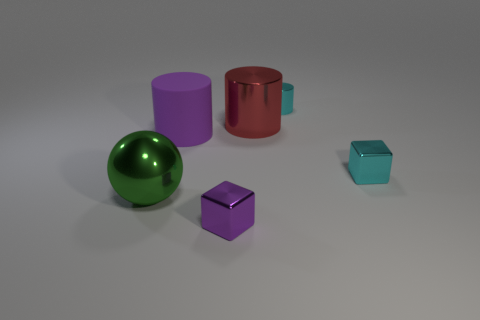Is there any other thing that has the same material as the big purple cylinder?
Make the answer very short. No. Is the shape of the small cyan object that is left of the cyan cube the same as the cyan shiny thing in front of the matte cylinder?
Provide a short and direct response. No. How many blocks are big red shiny objects or tiny purple metal things?
Ensure brevity in your answer.  1. What material is the purple thing that is behind the tiny cyan metal object in front of the large cylinder that is to the left of the purple metallic block?
Offer a very short reply. Rubber. How many other things are there of the same size as the red metal object?
Keep it short and to the point. 2. What is the size of the shiny cube that is the same color as the big rubber cylinder?
Make the answer very short. Small. Is the number of big metallic objects behind the big green metallic sphere greater than the number of red rubber cylinders?
Your answer should be compact. Yes. Are there any tiny blocks that have the same color as the rubber cylinder?
Keep it short and to the point. Yes. There is another cylinder that is the same size as the red metal cylinder; what color is it?
Your answer should be compact. Purple. There is a cyan metal object in front of the tiny cylinder; what number of large green objects are to the left of it?
Ensure brevity in your answer.  1. 